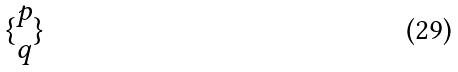Convert formula to latex. <formula><loc_0><loc_0><loc_500><loc_500>\{ \begin{matrix} p \\ q \end{matrix} \}</formula> 